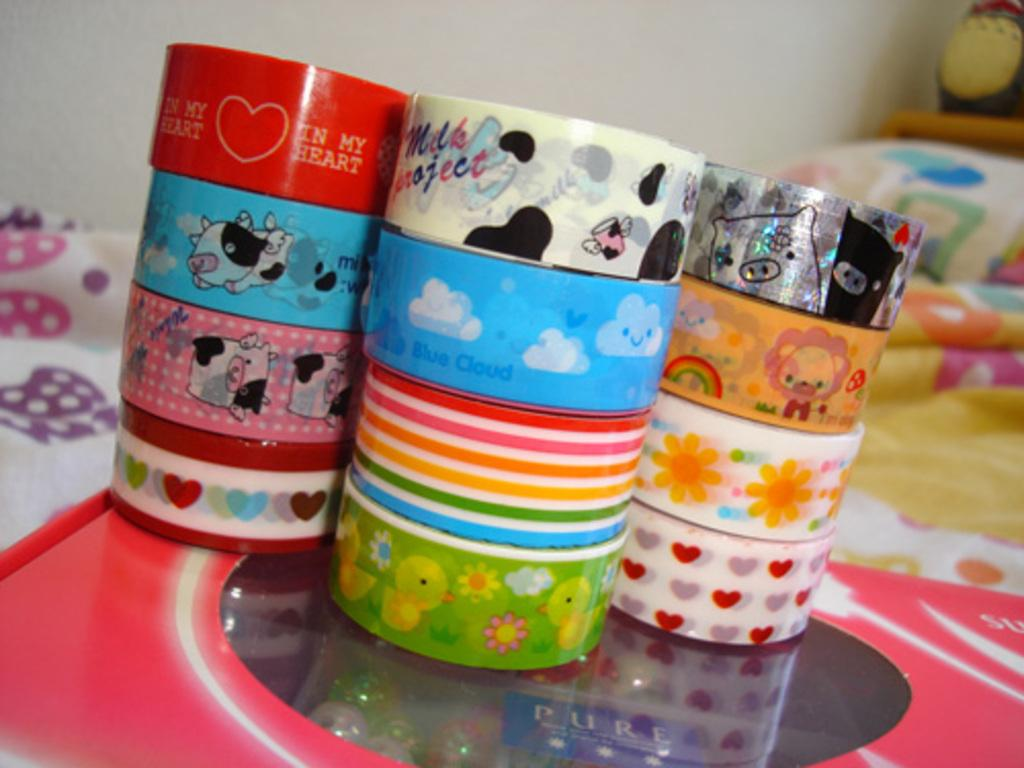What piece of furniture is present in the image? There is a bed in the image. What is placed on the bed? There is a box and plasters on the bed. What can be seen in the background of the image? There is a wall in the background of the image. How many chickens are visible on the bed in the image? There are no chickens present in the image. What type of gold object can be seen on the bed? There is no gold object present on the bed in the image. 